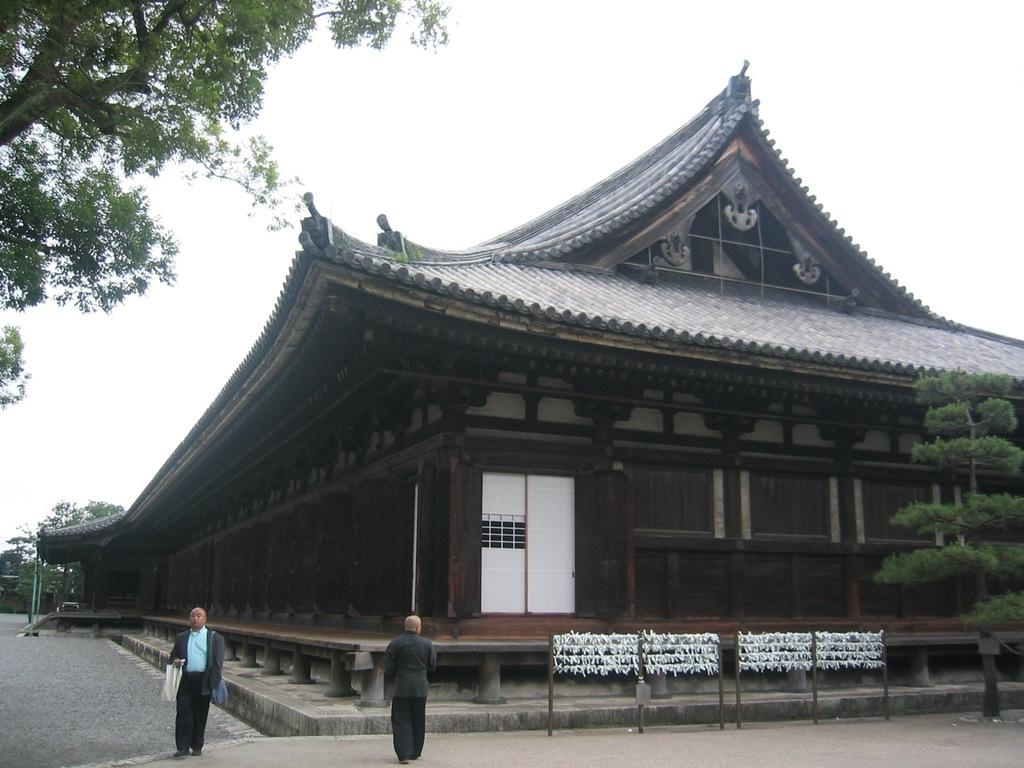What is being constructed in the image? There is a temple construction in the image. What are the people wearing in the image? The people in the image are wearing clothes. What type of path is visible in the image? There is a footpath in the image. What type of vegetation is present in the image? There are trees in the image. What is the color of the sky in the image? The sky is white in the image. What type of straw is being used by the band in the image? There is no band or straw present in the image. What type of basin is visible in the image? There is no basin present in the image. 